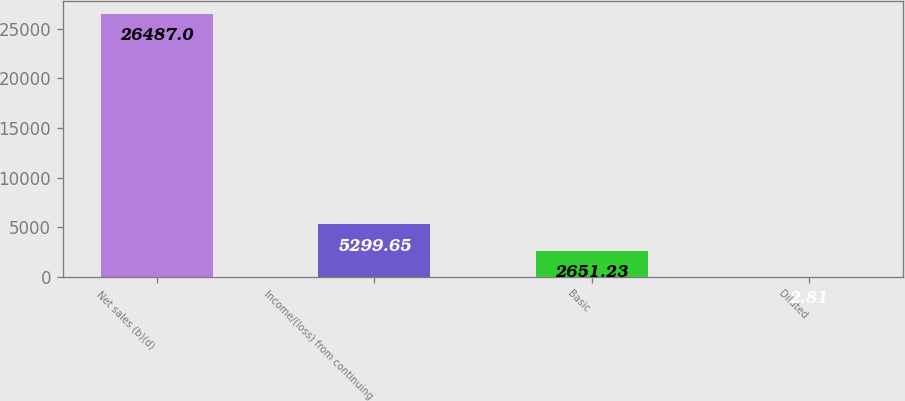<chart> <loc_0><loc_0><loc_500><loc_500><bar_chart><fcel>Net sales (b)(d)<fcel>Income/(loss) from continuing<fcel>Basic<fcel>Diluted<nl><fcel>26487<fcel>5299.65<fcel>2651.23<fcel>2.81<nl></chart> 